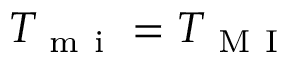<formula> <loc_0><loc_0><loc_500><loc_500>T _ { m i } = T _ { M I }</formula> 